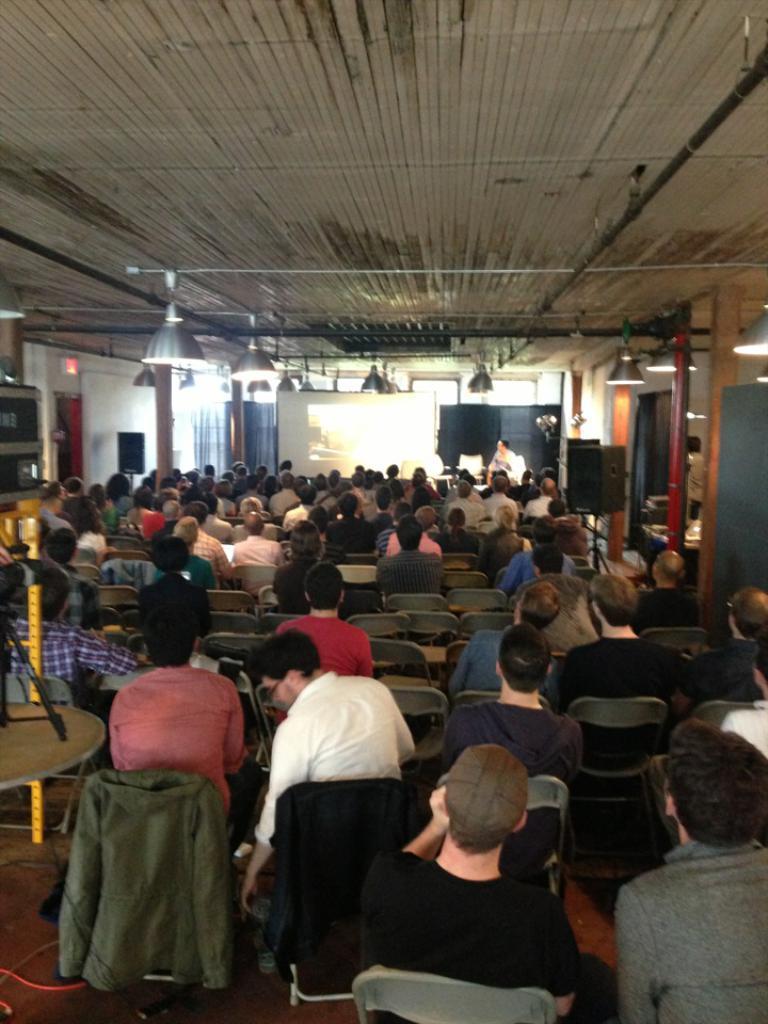How would you summarize this image in a sentence or two? In this picture we can see a group of people sitting on chairs, speakers, pillars, lights and in the background we can see a screen, windows. 